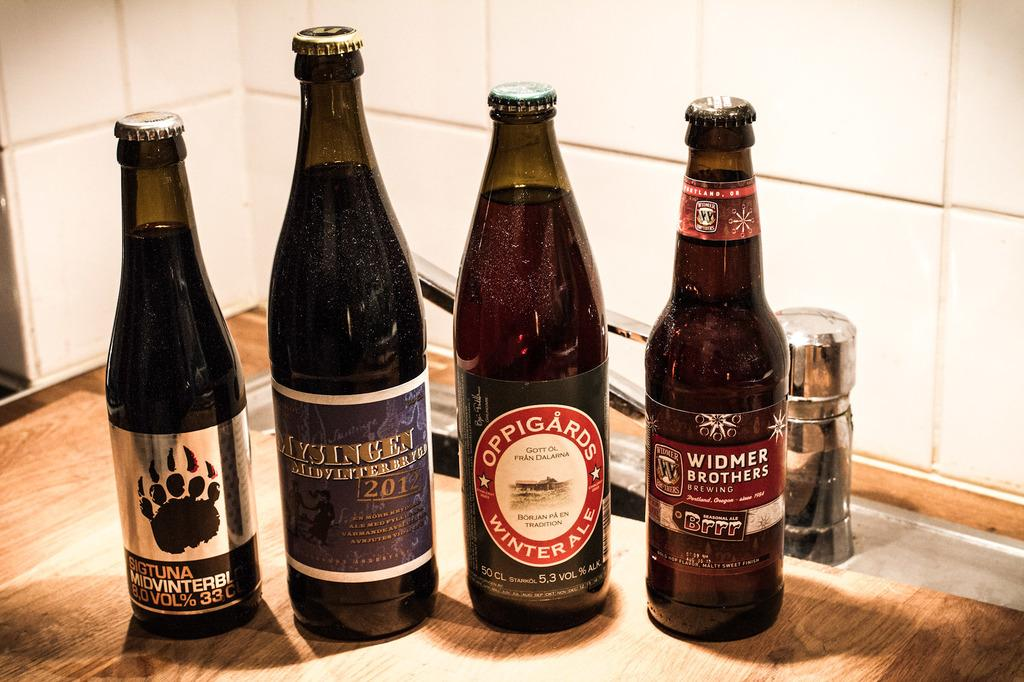<image>
Create a compact narrative representing the image presented. Four bottles are on the counter with one on the right from Widmer Brothers Brewing. 